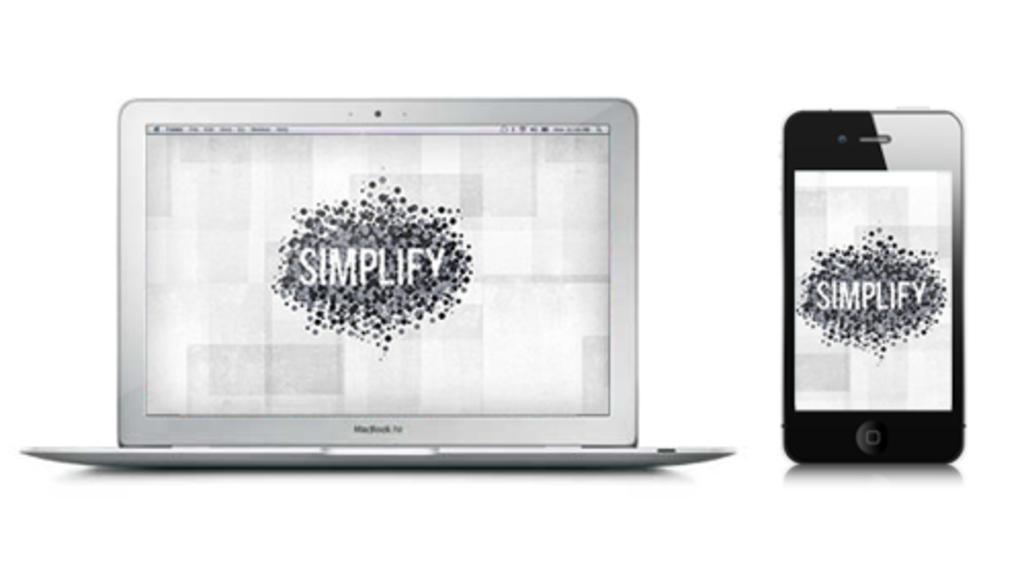Please provide a concise description of this image. In this image I can see a laptop and a mobile, and the image is in black and white. 